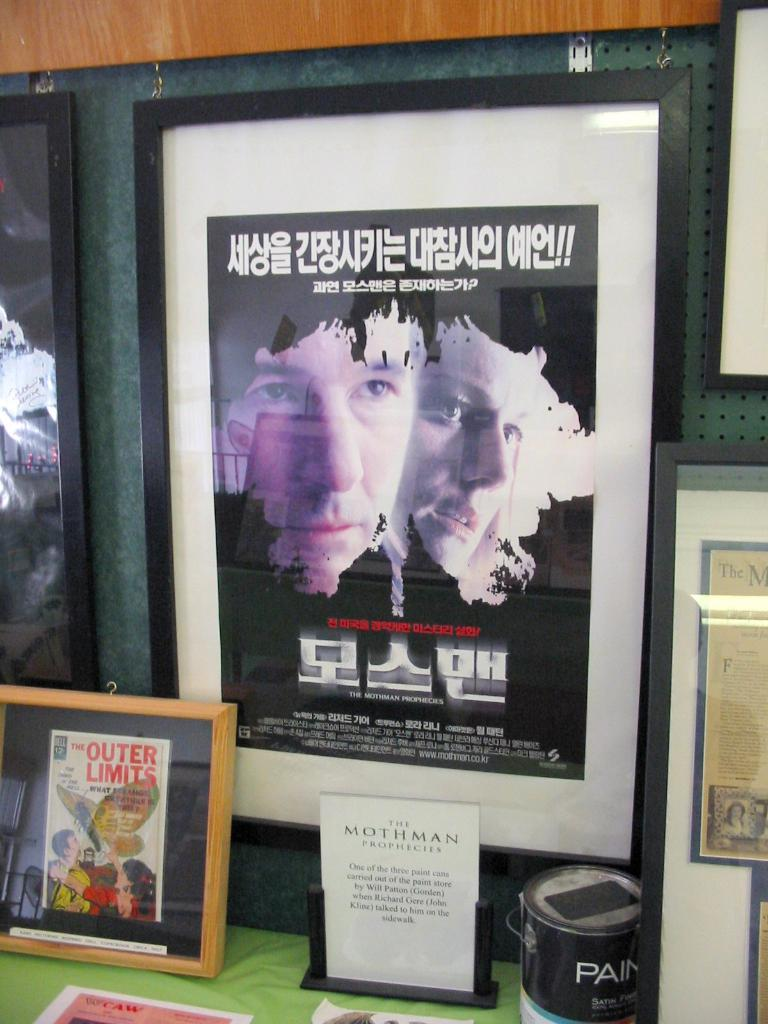What can be seen on the wall in the image? There are posts on the wall in the image. What is located on the table in the image? There is a photo frame, papers, a box, and other objects on the table in the image. Can you describe the photo frame on the table? The photo frame is on the table in the image. What else is present on the table besides the photo frame? There are papers and a box on the table, as well as other objects. How many waves can be seen in the image? There are no waves present in the image. What type of branch is hanging from the ceiling in the image? There is no branch hanging from the ceiling in the image. 